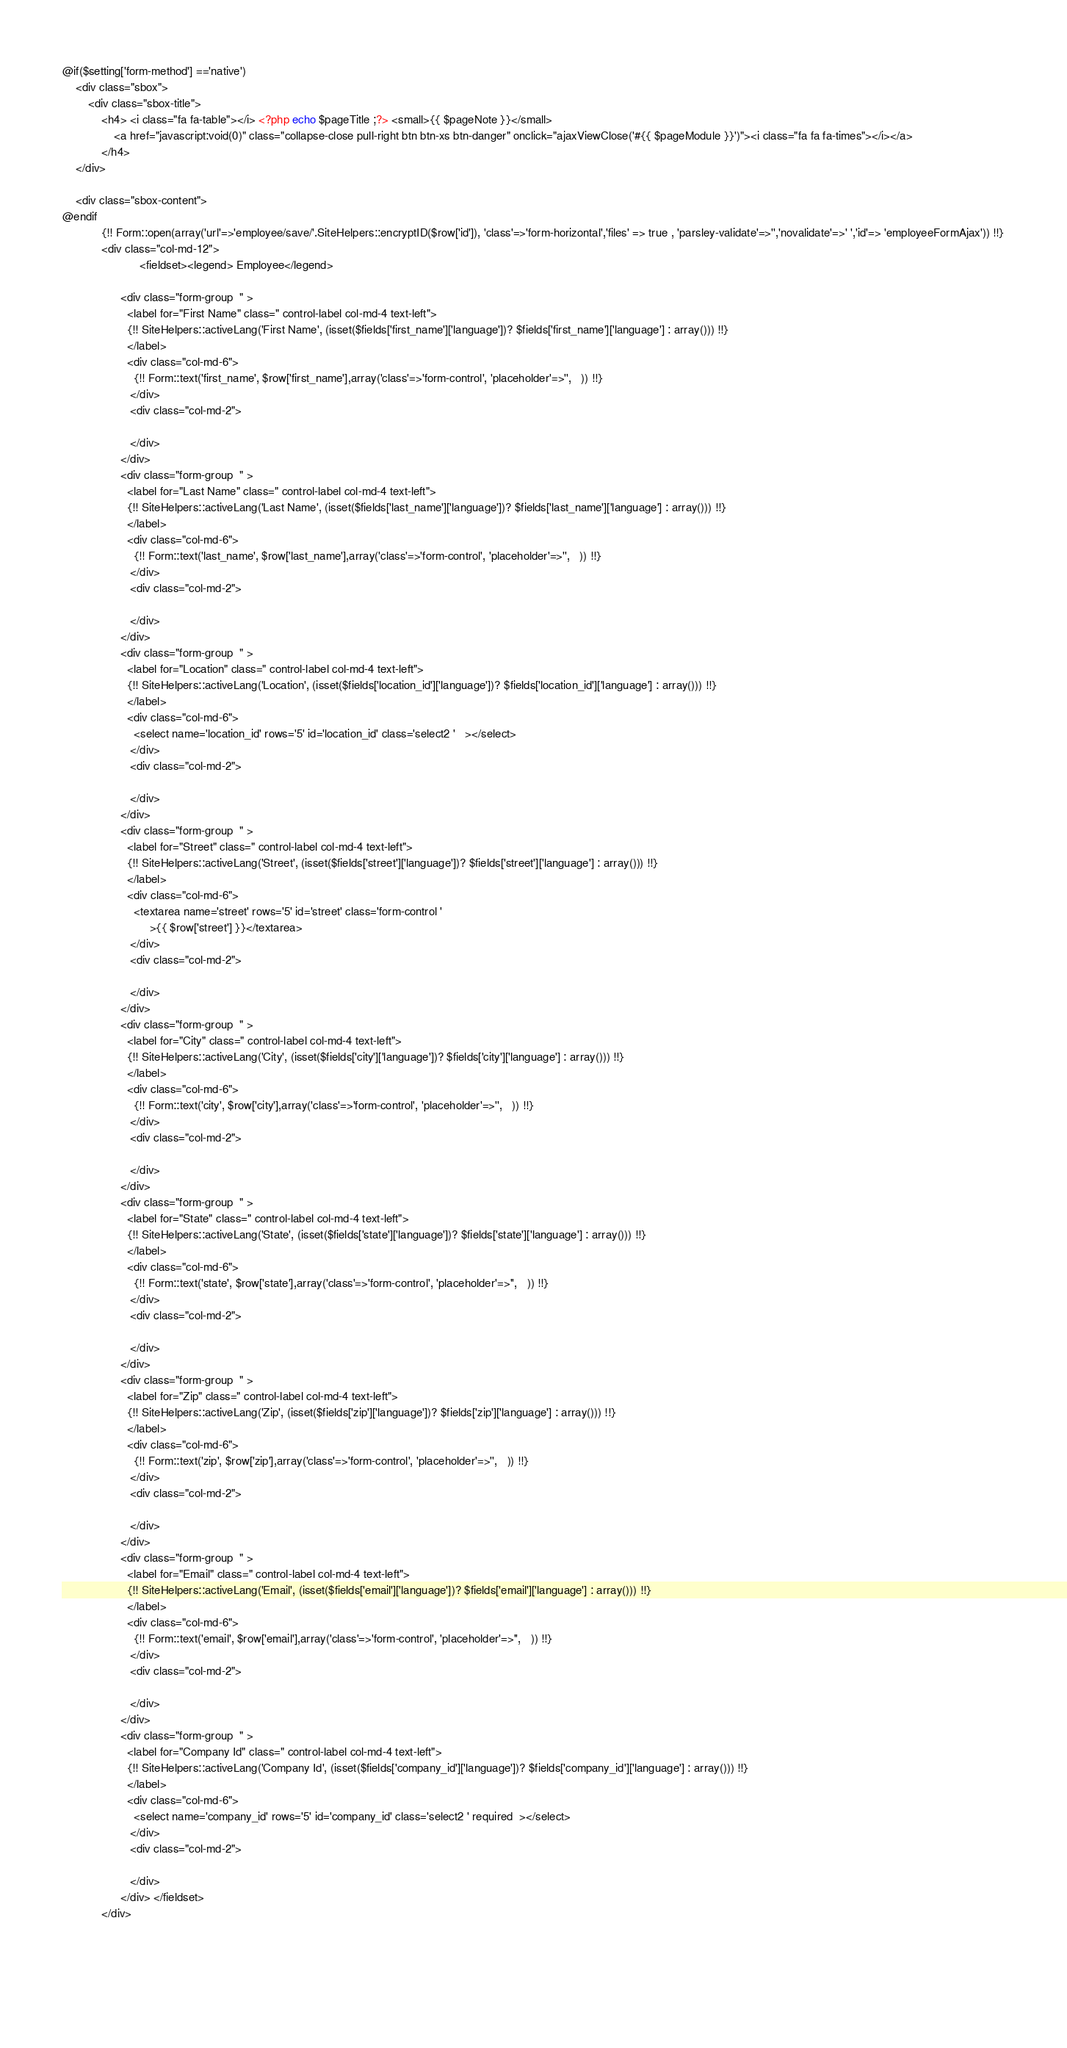<code> <loc_0><loc_0><loc_500><loc_500><_PHP_>
@if($setting['form-method'] =='native')
	<div class="sbox">
		<div class="sbox-title">  
			<h4> <i class="fa fa-table"></i> <?php echo $pageTitle ;?> <small>{{ $pageNote }}</small>
				<a href="javascript:void(0)" class="collapse-close pull-right btn btn-xs btn-danger" onclick="ajaxViewClose('#{{ $pageModule }}')"><i class="fa fa fa-times"></i></a>
			</h4>
	</div>

	<div class="sbox-content"> 
@endif	
			{!! Form::open(array('url'=>'employee/save/'.SiteHelpers::encryptID($row['id']), 'class'=>'form-horizontal','files' => true , 'parsley-validate'=>'','novalidate'=>' ','id'=> 'employeeFormAjax')) !!}
			<div class="col-md-12">
						<fieldset><legend> Employee</legend>
									
				  <div class="form-group  " > 
					<label for="First Name" class=" control-label col-md-4 text-left"> 
					{!! SiteHelpers::activeLang('First Name', (isset($fields['first_name']['language'])? $fields['first_name']['language'] : array())) !!}	
					</label>
					<div class="col-md-6">
					  {!! Form::text('first_name', $row['first_name'],array('class'=>'form-control', 'placeholder'=>'',   )) !!} 
					 </div> 
					 <div class="col-md-2">
					 	
					 </div>
				  </div> 					
				  <div class="form-group  " > 
					<label for="Last Name" class=" control-label col-md-4 text-left"> 
					{!! SiteHelpers::activeLang('Last Name', (isset($fields['last_name']['language'])? $fields['last_name']['language'] : array())) !!}	
					</label>
					<div class="col-md-6">
					  {!! Form::text('last_name', $row['last_name'],array('class'=>'form-control', 'placeholder'=>'',   )) !!} 
					 </div> 
					 <div class="col-md-2">
					 	
					 </div>
				  </div> 					
				  <div class="form-group  " > 
					<label for="Location" class=" control-label col-md-4 text-left"> 
					{!! SiteHelpers::activeLang('Location', (isset($fields['location_id']['language'])? $fields['location_id']['language'] : array())) !!}	
					</label>
					<div class="col-md-6">
					  <select name='location_id' rows='5' id='location_id' class='select2 '   ></select> 
					 </div> 
					 <div class="col-md-2">
					 	
					 </div>
				  </div> 					
				  <div class="form-group  " > 
					<label for="Street" class=" control-label col-md-4 text-left"> 
					{!! SiteHelpers::activeLang('Street', (isset($fields['street']['language'])? $fields['street']['language'] : array())) !!}	
					</label>
					<div class="col-md-6">
					  <textarea name='street' rows='5' id='street' class='form-control '  
				           >{{ $row['street'] }}</textarea> 
					 </div> 
					 <div class="col-md-2">
					 	
					 </div>
				  </div> 					
				  <div class="form-group  " > 
					<label for="City" class=" control-label col-md-4 text-left"> 
					{!! SiteHelpers::activeLang('City', (isset($fields['city']['language'])? $fields['city']['language'] : array())) !!}	
					</label>
					<div class="col-md-6">
					  {!! Form::text('city', $row['city'],array('class'=>'form-control', 'placeholder'=>'',   )) !!} 
					 </div> 
					 <div class="col-md-2">
					 	
					 </div>
				  </div> 					
				  <div class="form-group  " > 
					<label for="State" class=" control-label col-md-4 text-left"> 
					{!! SiteHelpers::activeLang('State', (isset($fields['state']['language'])? $fields['state']['language'] : array())) !!}	
					</label>
					<div class="col-md-6">
					  {!! Form::text('state', $row['state'],array('class'=>'form-control', 'placeholder'=>'',   )) !!} 
					 </div> 
					 <div class="col-md-2">
					 	
					 </div>
				  </div> 					
				  <div class="form-group  " > 
					<label for="Zip" class=" control-label col-md-4 text-left"> 
					{!! SiteHelpers::activeLang('Zip', (isset($fields['zip']['language'])? $fields['zip']['language'] : array())) !!}	
					</label>
					<div class="col-md-6">
					  {!! Form::text('zip', $row['zip'],array('class'=>'form-control', 'placeholder'=>'',   )) !!} 
					 </div> 
					 <div class="col-md-2">
					 	
					 </div>
				  </div> 					
				  <div class="form-group  " >
					<label for="Email" class=" control-label col-md-4 text-left">
					{!! SiteHelpers::activeLang('Email', (isset($fields['email']['language'])? $fields['email']['language'] : array())) !!}
					</label>
					<div class="col-md-6">
					  {!! Form::text('email', $row['email'],array('class'=>'form-control', 'placeholder'=>'',   )) !!}
					 </div>
					 <div class="col-md-2">

					 </div>
				  </div>
				  <div class="form-group  " > 
					<label for="Company Id" class=" control-label col-md-4 text-left"> 
					{!! SiteHelpers::activeLang('Company Id', (isset($fields['company_id']['language'])? $fields['company_id']['language'] : array())) !!}	
					</label>
					<div class="col-md-6">
					  <select name='company_id' rows='5' id='company_id' class='select2 ' required  ></select> 
					 </div> 
					 <div class="col-md-2">
					 	
					 </div>
				  </div> </fieldset>
			</div>
			
												
								
						</code> 